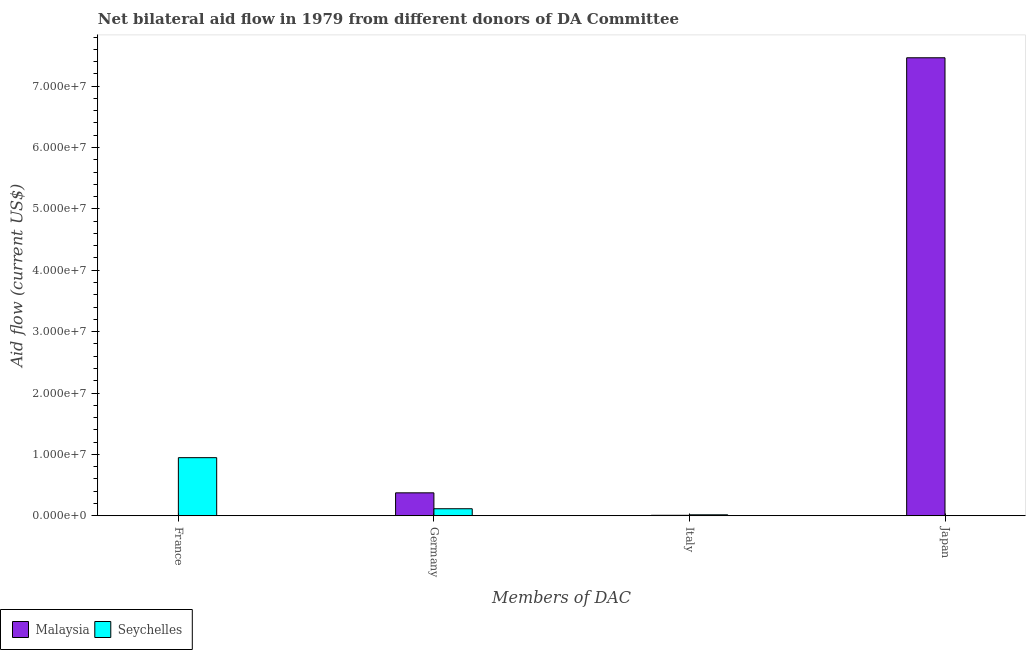How many different coloured bars are there?
Offer a very short reply. 2. Are the number of bars on each tick of the X-axis equal?
Offer a very short reply. No. How many bars are there on the 2nd tick from the left?
Ensure brevity in your answer.  2. What is the amount of aid given by japan in Malaysia?
Your answer should be compact. 7.46e+07. Across all countries, what is the maximum amount of aid given by italy?
Provide a succinct answer. 1.60e+05. Across all countries, what is the minimum amount of aid given by france?
Provide a short and direct response. 0. In which country was the amount of aid given by france maximum?
Your response must be concise. Seychelles. What is the total amount of aid given by france in the graph?
Make the answer very short. 9.47e+06. What is the difference between the amount of aid given by germany in Seychelles and that in Malaysia?
Ensure brevity in your answer.  -2.59e+06. What is the difference between the amount of aid given by france in Seychelles and the amount of aid given by japan in Malaysia?
Make the answer very short. -6.52e+07. What is the average amount of aid given by germany per country?
Your answer should be compact. 2.44e+06. What is the difference between the amount of aid given by italy and amount of aid given by germany in Seychelles?
Your answer should be compact. -9.90e+05. In how many countries, is the amount of aid given by france greater than 18000000 US$?
Offer a very short reply. 0. What is the ratio of the amount of aid given by germany in Seychelles to that in Malaysia?
Provide a succinct answer. 0.31. Is the amount of aid given by italy in Seychelles less than that in Malaysia?
Offer a very short reply. No. Is the difference between the amount of aid given by germany in Seychelles and Malaysia greater than the difference between the amount of aid given by italy in Seychelles and Malaysia?
Offer a very short reply. No. What is the difference between the highest and the second highest amount of aid given by italy?
Make the answer very short. 8.00e+04. What is the difference between the highest and the lowest amount of aid given by germany?
Ensure brevity in your answer.  2.59e+06. In how many countries, is the amount of aid given by italy greater than the average amount of aid given by italy taken over all countries?
Your response must be concise. 1. Is the sum of the amount of aid given by germany in Seychelles and Malaysia greater than the maximum amount of aid given by italy across all countries?
Offer a terse response. Yes. Is it the case that in every country, the sum of the amount of aid given by germany and amount of aid given by italy is greater than the sum of amount of aid given by japan and amount of aid given by france?
Offer a very short reply. Yes. What is the difference between two consecutive major ticks on the Y-axis?
Give a very brief answer. 1.00e+07. How are the legend labels stacked?
Your answer should be compact. Horizontal. What is the title of the graph?
Your response must be concise. Net bilateral aid flow in 1979 from different donors of DA Committee. What is the label or title of the X-axis?
Keep it short and to the point. Members of DAC. What is the Aid flow (current US$) of Malaysia in France?
Ensure brevity in your answer.  0. What is the Aid flow (current US$) in Seychelles in France?
Ensure brevity in your answer.  9.47e+06. What is the Aid flow (current US$) in Malaysia in Germany?
Keep it short and to the point. 3.74e+06. What is the Aid flow (current US$) of Seychelles in Germany?
Offer a terse response. 1.15e+06. What is the Aid flow (current US$) in Malaysia in Italy?
Give a very brief answer. 8.00e+04. What is the Aid flow (current US$) of Seychelles in Italy?
Your answer should be very brief. 1.60e+05. What is the Aid flow (current US$) of Malaysia in Japan?
Give a very brief answer. 7.46e+07. Across all Members of DAC, what is the maximum Aid flow (current US$) in Malaysia?
Provide a short and direct response. 7.46e+07. Across all Members of DAC, what is the maximum Aid flow (current US$) of Seychelles?
Ensure brevity in your answer.  9.47e+06. Across all Members of DAC, what is the minimum Aid flow (current US$) in Malaysia?
Give a very brief answer. 0. What is the total Aid flow (current US$) of Malaysia in the graph?
Provide a succinct answer. 7.84e+07. What is the total Aid flow (current US$) in Seychelles in the graph?
Your answer should be very brief. 1.08e+07. What is the difference between the Aid flow (current US$) in Seychelles in France and that in Germany?
Provide a short and direct response. 8.32e+06. What is the difference between the Aid flow (current US$) in Seychelles in France and that in Italy?
Make the answer very short. 9.31e+06. What is the difference between the Aid flow (current US$) of Seychelles in France and that in Japan?
Offer a terse response. 9.46e+06. What is the difference between the Aid flow (current US$) in Malaysia in Germany and that in Italy?
Give a very brief answer. 3.66e+06. What is the difference between the Aid flow (current US$) of Seychelles in Germany and that in Italy?
Make the answer very short. 9.90e+05. What is the difference between the Aid flow (current US$) of Malaysia in Germany and that in Japan?
Keep it short and to the point. -7.09e+07. What is the difference between the Aid flow (current US$) of Seychelles in Germany and that in Japan?
Your response must be concise. 1.14e+06. What is the difference between the Aid flow (current US$) of Malaysia in Italy and that in Japan?
Offer a terse response. -7.45e+07. What is the difference between the Aid flow (current US$) in Seychelles in Italy and that in Japan?
Your answer should be compact. 1.50e+05. What is the difference between the Aid flow (current US$) of Malaysia in Germany and the Aid flow (current US$) of Seychelles in Italy?
Provide a short and direct response. 3.58e+06. What is the difference between the Aid flow (current US$) in Malaysia in Germany and the Aid flow (current US$) in Seychelles in Japan?
Provide a short and direct response. 3.73e+06. What is the average Aid flow (current US$) in Malaysia per Members of DAC?
Your answer should be compact. 1.96e+07. What is the average Aid flow (current US$) in Seychelles per Members of DAC?
Keep it short and to the point. 2.70e+06. What is the difference between the Aid flow (current US$) of Malaysia and Aid flow (current US$) of Seychelles in Germany?
Ensure brevity in your answer.  2.59e+06. What is the difference between the Aid flow (current US$) in Malaysia and Aid flow (current US$) in Seychelles in Italy?
Provide a succinct answer. -8.00e+04. What is the difference between the Aid flow (current US$) of Malaysia and Aid flow (current US$) of Seychelles in Japan?
Ensure brevity in your answer.  7.46e+07. What is the ratio of the Aid flow (current US$) in Seychelles in France to that in Germany?
Give a very brief answer. 8.23. What is the ratio of the Aid flow (current US$) of Seychelles in France to that in Italy?
Your answer should be compact. 59.19. What is the ratio of the Aid flow (current US$) in Seychelles in France to that in Japan?
Your response must be concise. 947. What is the ratio of the Aid flow (current US$) of Malaysia in Germany to that in Italy?
Keep it short and to the point. 46.75. What is the ratio of the Aid flow (current US$) in Seychelles in Germany to that in Italy?
Make the answer very short. 7.19. What is the ratio of the Aid flow (current US$) in Malaysia in Germany to that in Japan?
Your answer should be compact. 0.05. What is the ratio of the Aid flow (current US$) in Seychelles in Germany to that in Japan?
Provide a succinct answer. 115. What is the ratio of the Aid flow (current US$) in Malaysia in Italy to that in Japan?
Your response must be concise. 0. What is the difference between the highest and the second highest Aid flow (current US$) in Malaysia?
Provide a succinct answer. 7.09e+07. What is the difference between the highest and the second highest Aid flow (current US$) of Seychelles?
Make the answer very short. 8.32e+06. What is the difference between the highest and the lowest Aid flow (current US$) of Malaysia?
Offer a very short reply. 7.46e+07. What is the difference between the highest and the lowest Aid flow (current US$) in Seychelles?
Give a very brief answer. 9.46e+06. 